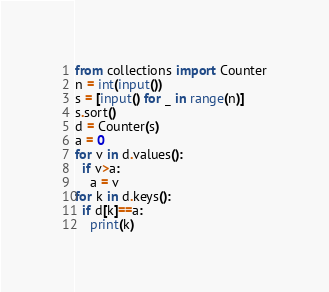<code> <loc_0><loc_0><loc_500><loc_500><_Python_>from collections import Counter
n = int(input())
s = [input() for _ in range(n)]
s.sort()
d = Counter(s)
a = 0
for v in d.values():
  if v>a:
    a = v
for k in d.keys():
  if d[k]==a:
    print(k)</code> 